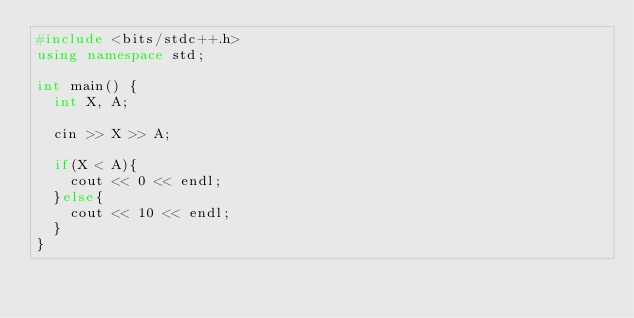Convert code to text. <code><loc_0><loc_0><loc_500><loc_500><_C++_>#include <bits/stdc++.h>
using namespace std;

int main() {
  int X, A;
  
  cin >> X >> A;
  
  if(X < A){
    cout << 0 << endl;
  }else{
    cout << 10 << endl;
  }
}</code> 